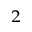<formula> <loc_0><loc_0><loc_500><loc_500>^ { 2 }</formula> 